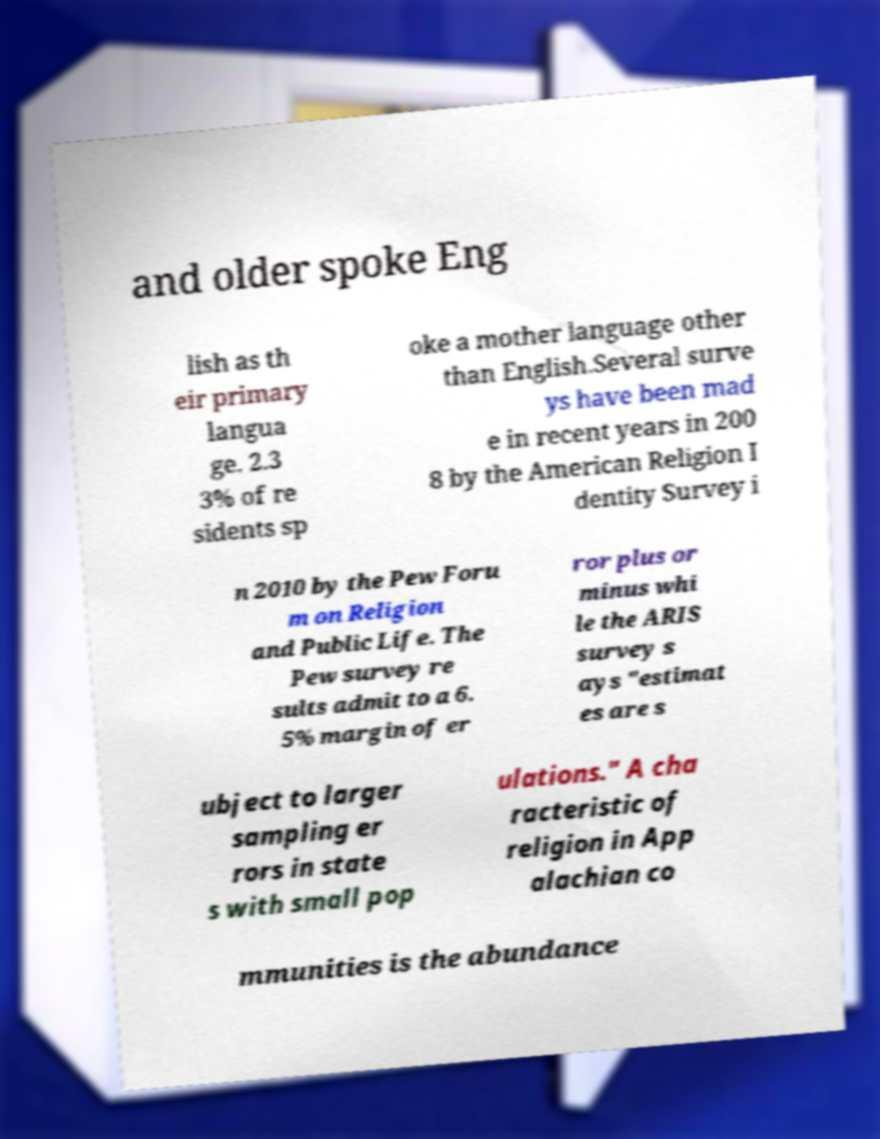Please read and relay the text visible in this image. What does it say? and older spoke Eng lish as th eir primary langua ge. 2.3 3% of re sidents sp oke a mother language other than English.Several surve ys have been mad e in recent years in 200 8 by the American Religion I dentity Survey i n 2010 by the Pew Foru m on Religion and Public Life. The Pew survey re sults admit to a 6. 5% margin of er ror plus or minus whi le the ARIS survey s ays "estimat es are s ubject to larger sampling er rors in state s with small pop ulations." A cha racteristic of religion in App alachian co mmunities is the abundance 